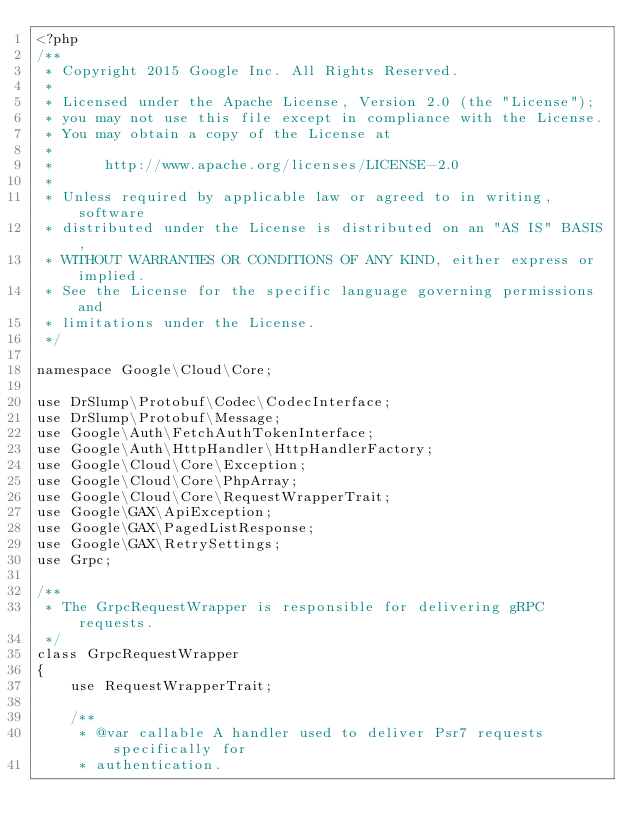Convert code to text. <code><loc_0><loc_0><loc_500><loc_500><_PHP_><?php
/**
 * Copyright 2015 Google Inc. All Rights Reserved.
 *
 * Licensed under the Apache License, Version 2.0 (the "License");
 * you may not use this file except in compliance with the License.
 * You may obtain a copy of the License at
 *
 *      http://www.apache.org/licenses/LICENSE-2.0
 *
 * Unless required by applicable law or agreed to in writing, software
 * distributed under the License is distributed on an "AS IS" BASIS,
 * WITHOUT WARRANTIES OR CONDITIONS OF ANY KIND, either express or implied.
 * See the License for the specific language governing permissions and
 * limitations under the License.
 */

namespace Google\Cloud\Core;

use DrSlump\Protobuf\Codec\CodecInterface;
use DrSlump\Protobuf\Message;
use Google\Auth\FetchAuthTokenInterface;
use Google\Auth\HttpHandler\HttpHandlerFactory;
use Google\Cloud\Core\Exception;
use Google\Cloud\Core\PhpArray;
use Google\Cloud\Core\RequestWrapperTrait;
use Google\GAX\ApiException;
use Google\GAX\PagedListResponse;
use Google\GAX\RetrySettings;
use Grpc;

/**
 * The GrpcRequestWrapper is responsible for delivering gRPC requests.
 */
class GrpcRequestWrapper
{
    use RequestWrapperTrait;

    /**
     * @var callable A handler used to deliver Psr7 requests specifically for
     * authentication.</code> 